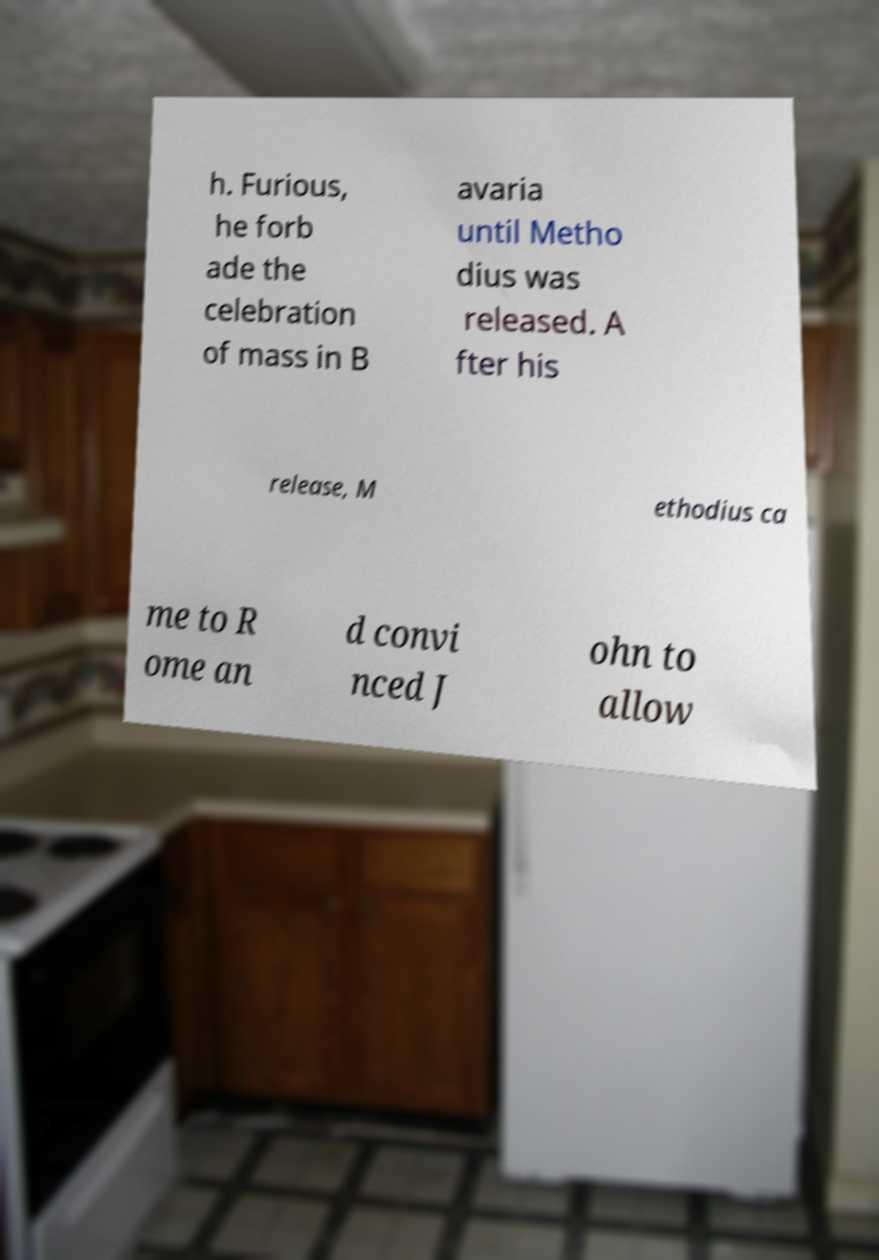Can you read and provide the text displayed in the image?This photo seems to have some interesting text. Can you extract and type it out for me? h. Furious, he forb ade the celebration of mass in B avaria until Metho dius was released. A fter his release, M ethodius ca me to R ome an d convi nced J ohn to allow 